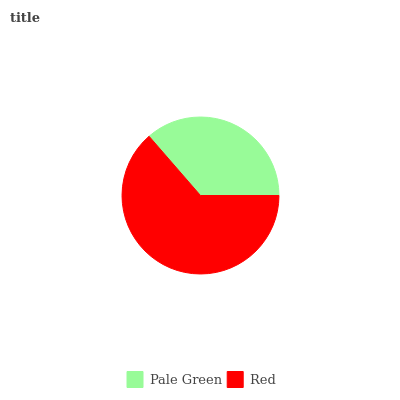Is Pale Green the minimum?
Answer yes or no. Yes. Is Red the maximum?
Answer yes or no. Yes. Is Red the minimum?
Answer yes or no. No. Is Red greater than Pale Green?
Answer yes or no. Yes. Is Pale Green less than Red?
Answer yes or no. Yes. Is Pale Green greater than Red?
Answer yes or no. No. Is Red less than Pale Green?
Answer yes or no. No. Is Red the high median?
Answer yes or no. Yes. Is Pale Green the low median?
Answer yes or no. Yes. Is Pale Green the high median?
Answer yes or no. No. Is Red the low median?
Answer yes or no. No. 